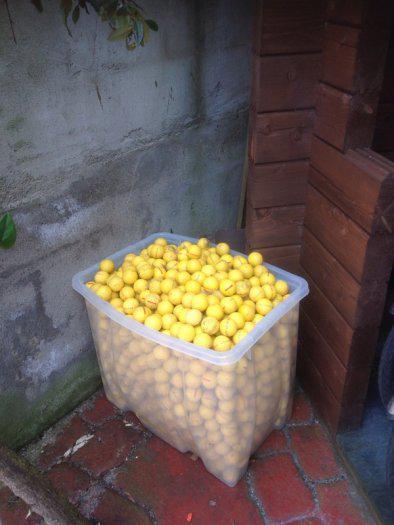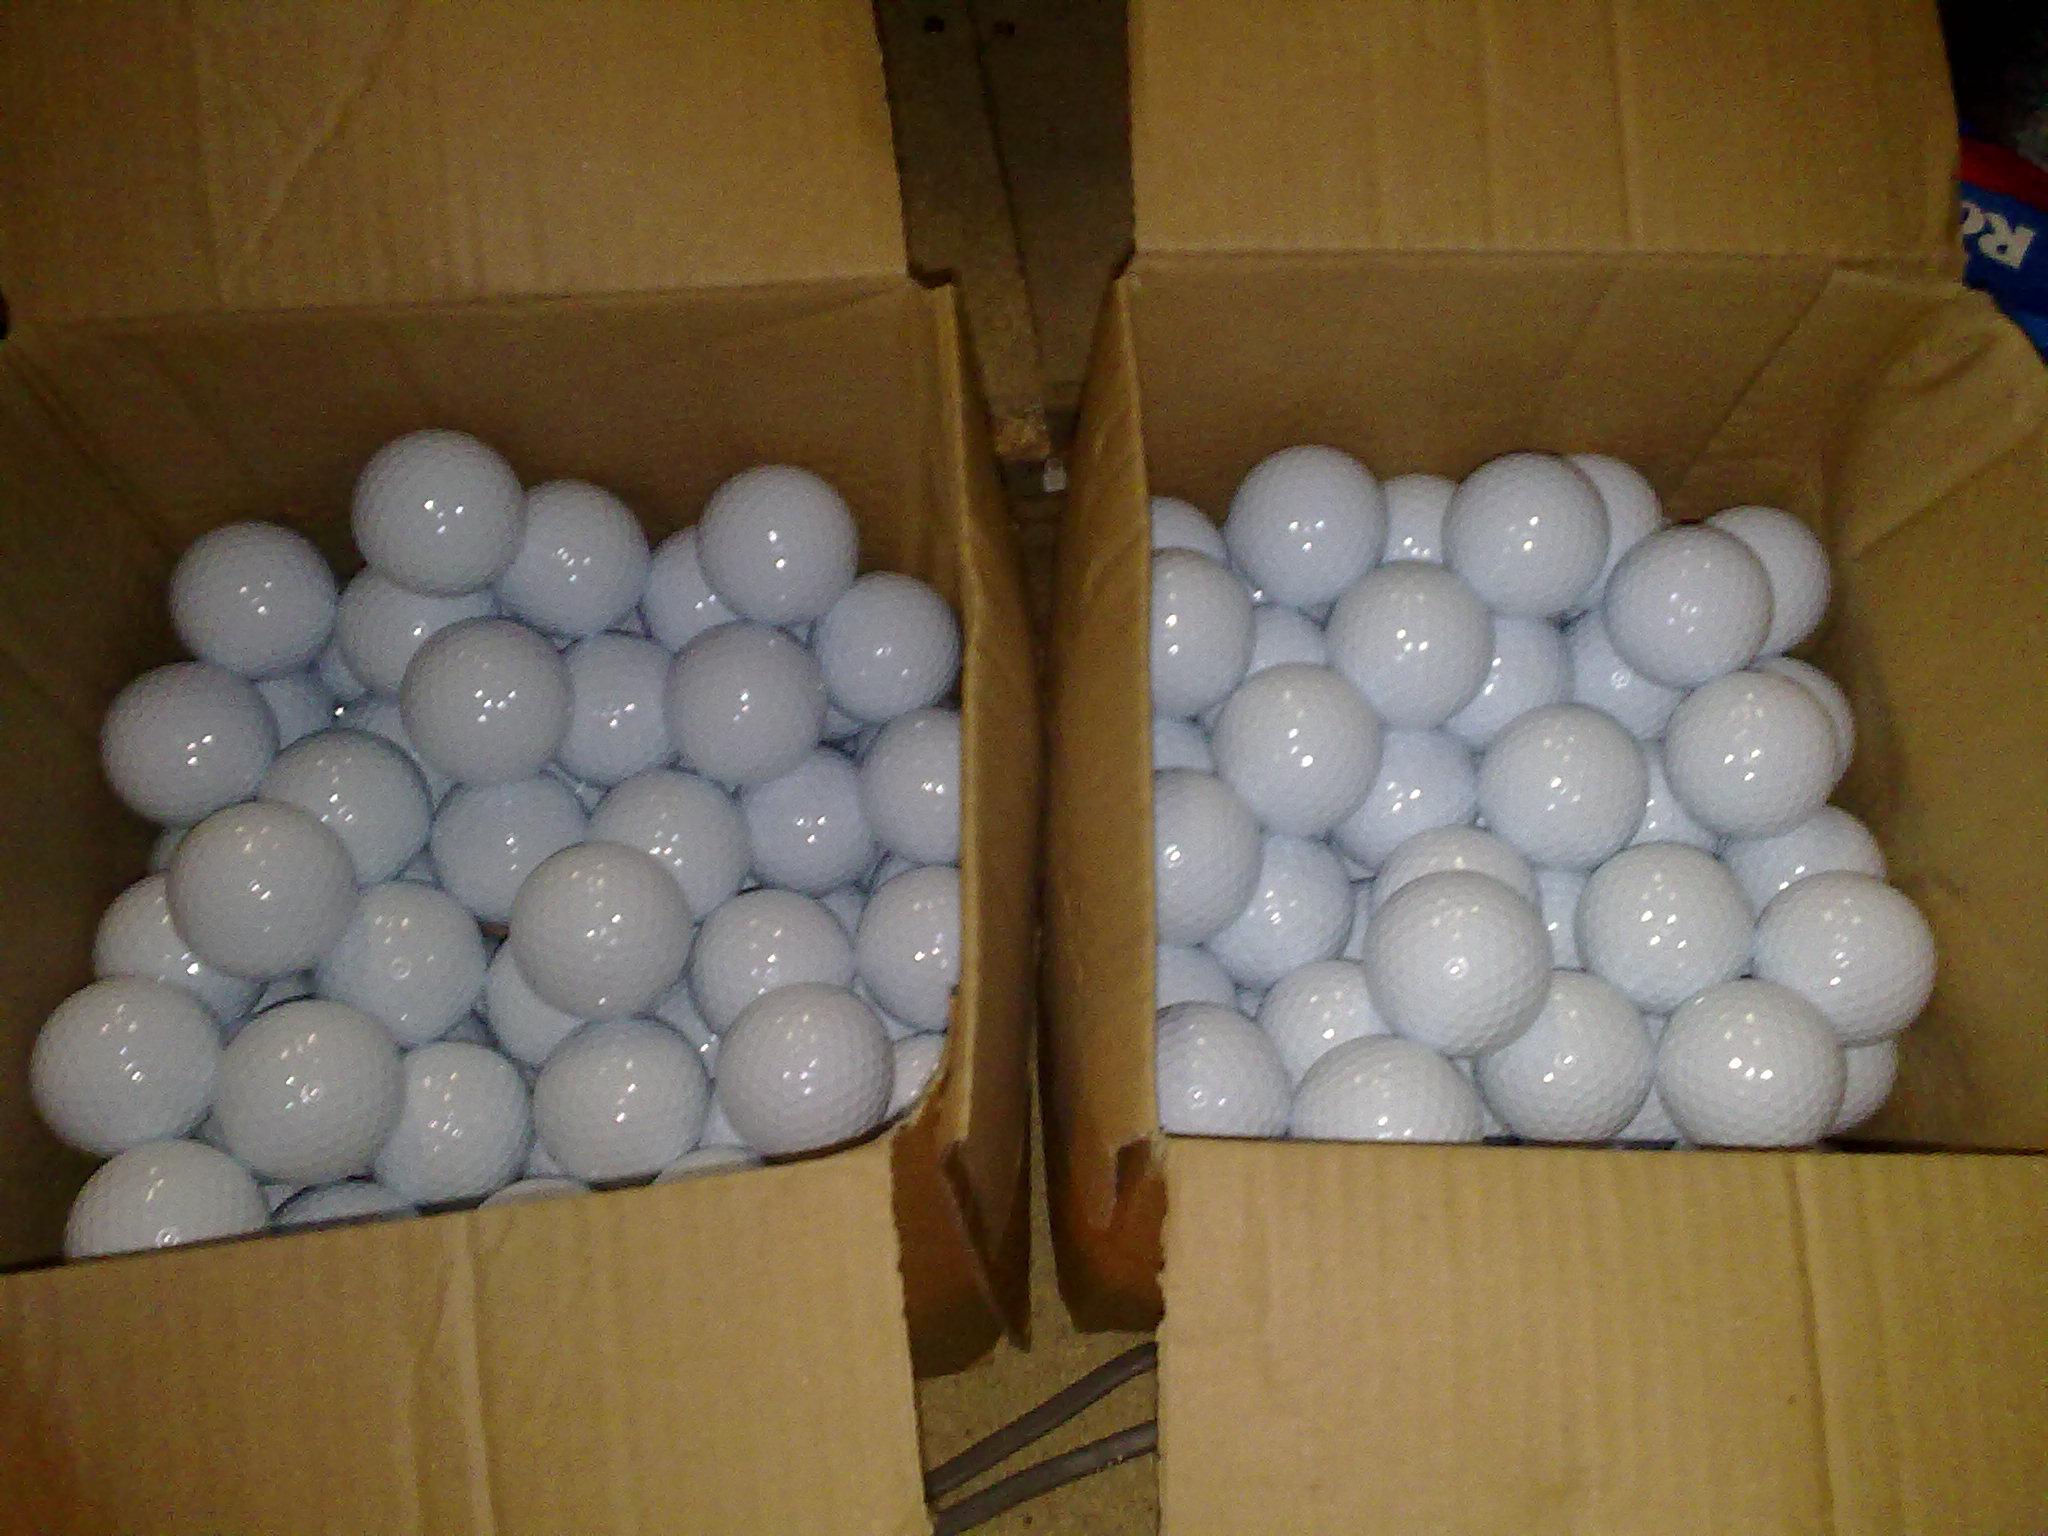The first image is the image on the left, the second image is the image on the right. For the images shown, is this caption "One image shows a golf ball bucket with at least two bright orange balls." true? Answer yes or no. No. The first image is the image on the left, the second image is the image on the right. For the images displayed, is the sentence "There are two cardboard boxes in the image on the right." factually correct? Answer yes or no. Yes. 